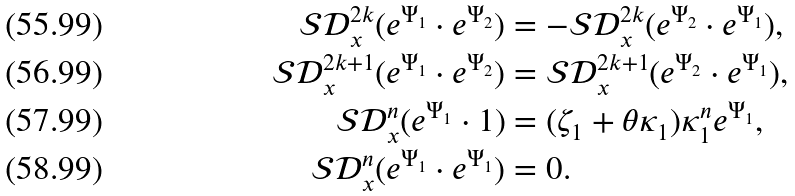Convert formula to latex. <formula><loc_0><loc_0><loc_500><loc_500>\mathcal { S } \mathcal { D } _ { x } ^ { 2 k } ( e ^ { \Psi _ { 1 } } \cdot e ^ { \Psi _ { 2 } } ) & = - \mathcal { S } \mathcal { D } _ { x } ^ { 2 k } ( e ^ { \Psi _ { 2 } } \cdot e ^ { \Psi _ { 1 } } ) , \\ \mathcal { S } \mathcal { D } _ { x } ^ { 2 k + 1 } ( e ^ { \Psi _ { 1 } } \cdot e ^ { \Psi _ { 2 } } ) & = \mathcal { S } \mathcal { D } _ { x } ^ { 2 k + 1 } ( e ^ { \Psi _ { 2 } } \cdot e ^ { \Psi _ { 1 } } ) , \\ \mathcal { S } \mathcal { D } _ { x } ^ { n } ( e ^ { \Psi _ { 1 } } \cdot 1 ) & = ( \zeta _ { 1 } + \theta \kappa _ { 1 } ) \kappa _ { 1 } ^ { n } e ^ { \Psi _ { 1 } } , \\ \mathcal { S } \mathcal { D } _ { x } ^ { n } ( e ^ { \Psi _ { 1 } } \cdot e ^ { \Psi _ { 1 } } ) & = 0 .</formula> 